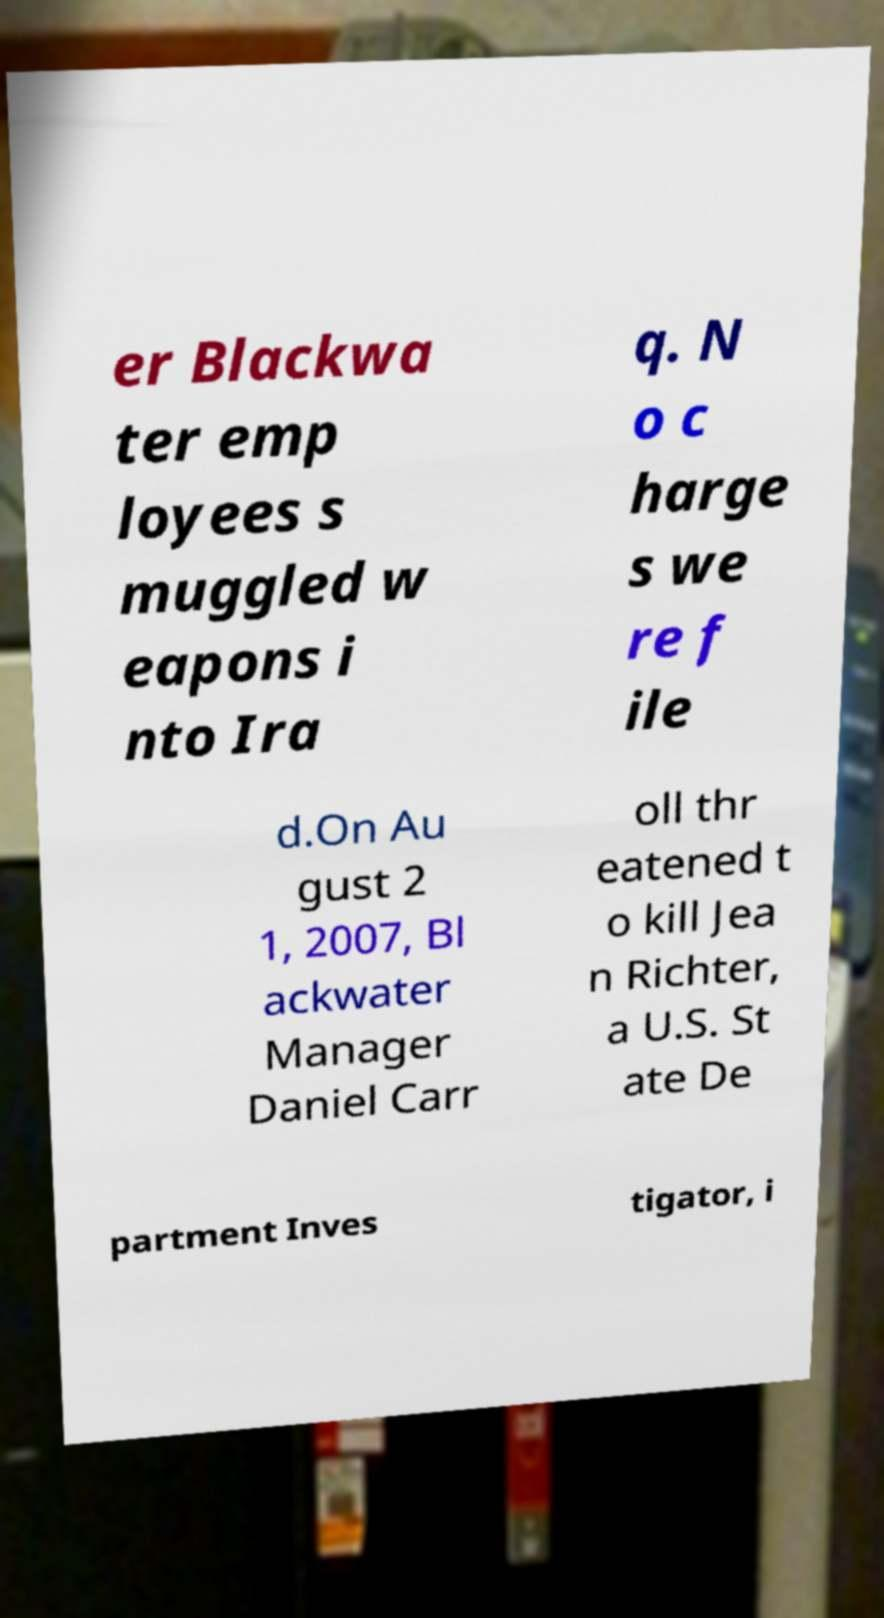Can you accurately transcribe the text from the provided image for me? er Blackwa ter emp loyees s muggled w eapons i nto Ira q. N o c harge s we re f ile d.On Au gust 2 1, 2007, Bl ackwater Manager Daniel Carr oll thr eatened t o kill Jea n Richter, a U.S. St ate De partment Inves tigator, i 